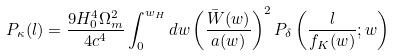<formula> <loc_0><loc_0><loc_500><loc_500>P _ { \kappa } ( l ) = \frac { 9 H _ { 0 } ^ { 4 } \Omega _ { m } ^ { 2 } } { 4 c ^ { 4 } } \int _ { 0 } ^ { w _ { H } } d w \left ( \frac { \bar { W } ( w ) } { a ( w ) } \right ) ^ { 2 } P _ { \delta } \left ( \frac { l } { f _ { K } ( w ) } ; w \right )</formula> 